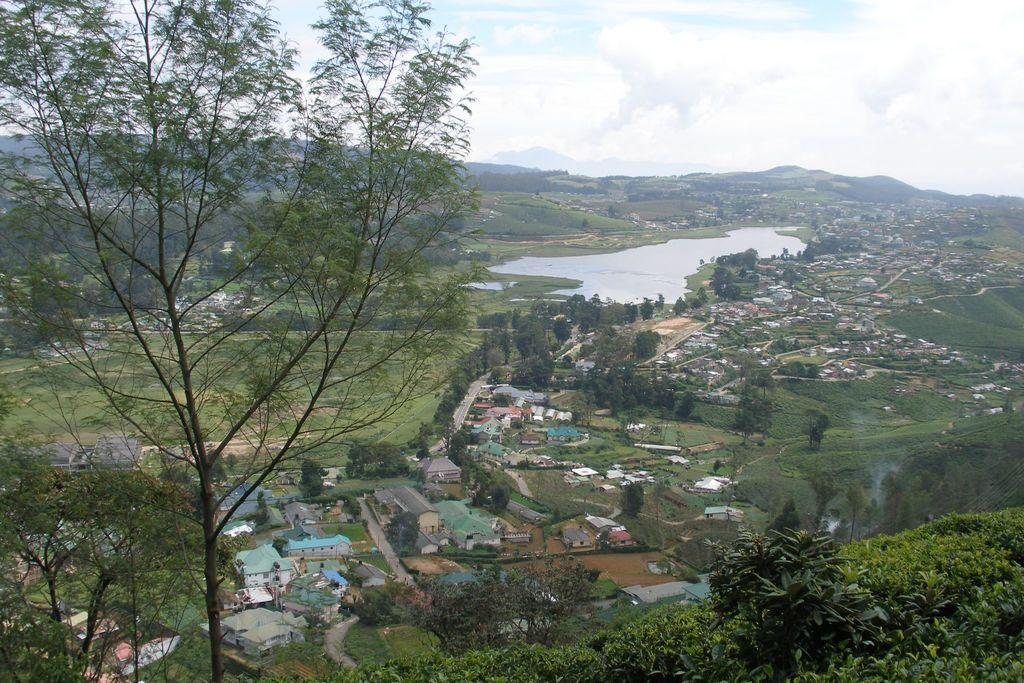What type of vegetation is present in the image? There are many trees in the image. What structures can be seen in the image? There are buildings in the image. What natural element is visible in the image? There is water visible in the image. What type of ground cover is present in the image? There is grass on the ground in the image. What type of shoe can be seen floating in the water in the image? There is no shoe present in the image; it only features trees, buildings, water, and grass. 